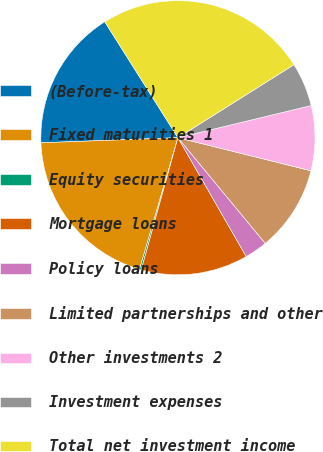Convert chart. <chart><loc_0><loc_0><loc_500><loc_500><pie_chart><fcel>(Before-tax)<fcel>Fixed maturities 1<fcel>Equity securities<fcel>Mortgage loans<fcel>Policy loans<fcel>Limited partnerships and other<fcel>Other investments 2<fcel>Investment expenses<fcel>Total net investment income<nl><fcel>16.64%<fcel>19.89%<fcel>0.21%<fcel>12.61%<fcel>2.69%<fcel>10.13%<fcel>7.65%<fcel>5.17%<fcel>25.02%<nl></chart> 